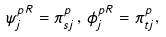Convert formula to latex. <formula><loc_0><loc_0><loc_500><loc_500>\psi ^ { p R } _ { j } = \pi ^ { p } _ { s j } \, , \, \phi ^ { p R } _ { j } = \pi ^ { p } _ { t j } ,</formula> 